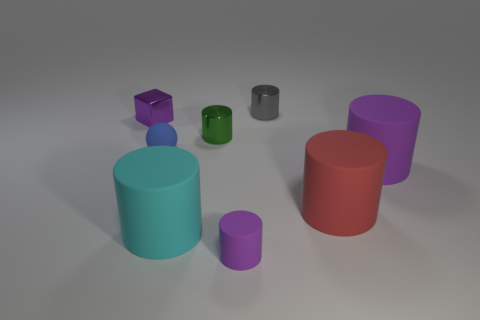What is the shape of the big object that is the same color as the block?
Give a very brief answer. Cylinder. What number of other things are the same size as the green metallic cylinder?
Keep it short and to the point. 4. Are there more tiny gray metallic things than large objects?
Provide a short and direct response. No. How many objects are to the right of the big cyan rubber object and in front of the rubber sphere?
Keep it short and to the point. 3. What is the shape of the small matte thing that is behind the purple cylinder that is to the left of the purple matte thing on the right side of the small purple cylinder?
Your answer should be compact. Sphere. Are there any other things that have the same shape as the big purple thing?
Provide a short and direct response. Yes. How many balls are large purple rubber things or blue objects?
Ensure brevity in your answer.  1. Do the small matte thing to the right of the small blue thing and the metallic block have the same color?
Your response must be concise. Yes. There is a cylinder behind the thing that is on the left side of the tiny rubber thing that is on the left side of the green cylinder; what is its material?
Give a very brief answer. Metal. Do the gray cylinder and the blue rubber thing have the same size?
Provide a short and direct response. Yes. 